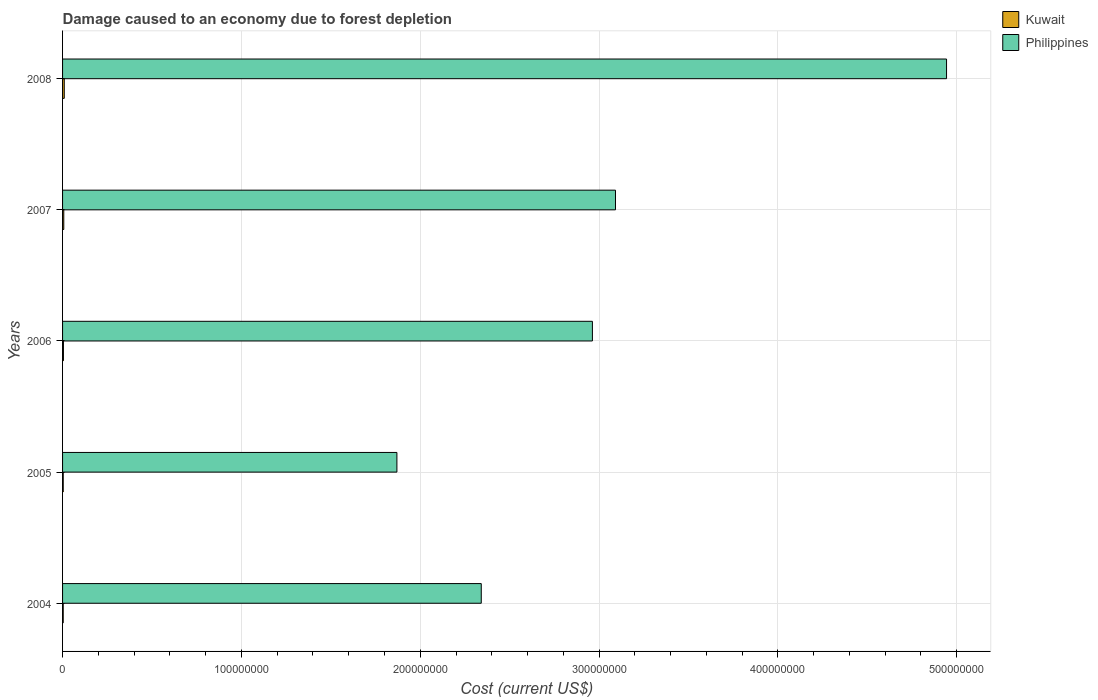How many different coloured bars are there?
Provide a short and direct response. 2. Are the number of bars on each tick of the Y-axis equal?
Keep it short and to the point. Yes. How many bars are there on the 5th tick from the top?
Your response must be concise. 2. What is the label of the 2nd group of bars from the top?
Your response must be concise. 2007. What is the cost of damage caused due to forest depletion in Philippines in 2007?
Your response must be concise. 3.09e+08. Across all years, what is the maximum cost of damage caused due to forest depletion in Kuwait?
Provide a short and direct response. 9.52e+05. Across all years, what is the minimum cost of damage caused due to forest depletion in Philippines?
Keep it short and to the point. 1.87e+08. In which year was the cost of damage caused due to forest depletion in Kuwait maximum?
Your response must be concise. 2008. What is the total cost of damage caused due to forest depletion in Philippines in the graph?
Give a very brief answer. 1.52e+09. What is the difference between the cost of damage caused due to forest depletion in Philippines in 2004 and that in 2006?
Offer a very short reply. -6.21e+07. What is the difference between the cost of damage caused due to forest depletion in Kuwait in 2005 and the cost of damage caused due to forest depletion in Philippines in 2008?
Offer a very short reply. -4.94e+08. What is the average cost of damage caused due to forest depletion in Philippines per year?
Give a very brief answer. 3.04e+08. In the year 2004, what is the difference between the cost of damage caused due to forest depletion in Philippines and cost of damage caused due to forest depletion in Kuwait?
Make the answer very short. 2.34e+08. What is the ratio of the cost of damage caused due to forest depletion in Kuwait in 2006 to that in 2008?
Ensure brevity in your answer.  0.51. What is the difference between the highest and the second highest cost of damage caused due to forest depletion in Philippines?
Provide a succinct answer. 1.85e+08. What is the difference between the highest and the lowest cost of damage caused due to forest depletion in Philippines?
Offer a very short reply. 3.07e+08. What does the 2nd bar from the top in 2004 represents?
Keep it short and to the point. Kuwait. What does the 2nd bar from the bottom in 2007 represents?
Your answer should be compact. Philippines. How many bars are there?
Make the answer very short. 10. How many years are there in the graph?
Provide a succinct answer. 5. What is the difference between two consecutive major ticks on the X-axis?
Give a very brief answer. 1.00e+08. Are the values on the major ticks of X-axis written in scientific E-notation?
Provide a short and direct response. No. How are the legend labels stacked?
Offer a terse response. Vertical. What is the title of the graph?
Offer a terse response. Damage caused to an economy due to forest depletion. What is the label or title of the X-axis?
Your answer should be very brief. Cost (current US$). What is the Cost (current US$) of Kuwait in 2004?
Make the answer very short. 3.68e+05. What is the Cost (current US$) in Philippines in 2004?
Your answer should be very brief. 2.34e+08. What is the Cost (current US$) of Kuwait in 2005?
Offer a terse response. 3.75e+05. What is the Cost (current US$) of Philippines in 2005?
Offer a very short reply. 1.87e+08. What is the Cost (current US$) in Kuwait in 2006?
Offer a very short reply. 4.88e+05. What is the Cost (current US$) in Philippines in 2006?
Offer a very short reply. 2.96e+08. What is the Cost (current US$) in Kuwait in 2007?
Offer a terse response. 6.83e+05. What is the Cost (current US$) in Philippines in 2007?
Make the answer very short. 3.09e+08. What is the Cost (current US$) of Kuwait in 2008?
Provide a succinct answer. 9.52e+05. What is the Cost (current US$) of Philippines in 2008?
Make the answer very short. 4.94e+08. Across all years, what is the maximum Cost (current US$) in Kuwait?
Keep it short and to the point. 9.52e+05. Across all years, what is the maximum Cost (current US$) of Philippines?
Your answer should be very brief. 4.94e+08. Across all years, what is the minimum Cost (current US$) of Kuwait?
Provide a short and direct response. 3.68e+05. Across all years, what is the minimum Cost (current US$) in Philippines?
Ensure brevity in your answer.  1.87e+08. What is the total Cost (current US$) in Kuwait in the graph?
Ensure brevity in your answer.  2.87e+06. What is the total Cost (current US$) in Philippines in the graph?
Provide a succinct answer. 1.52e+09. What is the difference between the Cost (current US$) of Kuwait in 2004 and that in 2005?
Give a very brief answer. -6623.41. What is the difference between the Cost (current US$) of Philippines in 2004 and that in 2005?
Your response must be concise. 4.72e+07. What is the difference between the Cost (current US$) of Kuwait in 2004 and that in 2006?
Your answer should be compact. -1.20e+05. What is the difference between the Cost (current US$) of Philippines in 2004 and that in 2006?
Give a very brief answer. -6.21e+07. What is the difference between the Cost (current US$) of Kuwait in 2004 and that in 2007?
Your response must be concise. -3.15e+05. What is the difference between the Cost (current US$) of Philippines in 2004 and that in 2007?
Offer a very short reply. -7.51e+07. What is the difference between the Cost (current US$) in Kuwait in 2004 and that in 2008?
Provide a succinct answer. -5.84e+05. What is the difference between the Cost (current US$) of Philippines in 2004 and that in 2008?
Your answer should be very brief. -2.60e+08. What is the difference between the Cost (current US$) of Kuwait in 2005 and that in 2006?
Your answer should be compact. -1.13e+05. What is the difference between the Cost (current US$) in Philippines in 2005 and that in 2006?
Offer a very short reply. -1.09e+08. What is the difference between the Cost (current US$) of Kuwait in 2005 and that in 2007?
Ensure brevity in your answer.  -3.09e+05. What is the difference between the Cost (current US$) in Philippines in 2005 and that in 2007?
Offer a terse response. -1.22e+08. What is the difference between the Cost (current US$) of Kuwait in 2005 and that in 2008?
Your answer should be compact. -5.77e+05. What is the difference between the Cost (current US$) of Philippines in 2005 and that in 2008?
Give a very brief answer. -3.07e+08. What is the difference between the Cost (current US$) of Kuwait in 2006 and that in 2007?
Your response must be concise. -1.96e+05. What is the difference between the Cost (current US$) of Philippines in 2006 and that in 2007?
Ensure brevity in your answer.  -1.29e+07. What is the difference between the Cost (current US$) in Kuwait in 2006 and that in 2008?
Give a very brief answer. -4.64e+05. What is the difference between the Cost (current US$) of Philippines in 2006 and that in 2008?
Your answer should be compact. -1.98e+08. What is the difference between the Cost (current US$) of Kuwait in 2007 and that in 2008?
Offer a very short reply. -2.69e+05. What is the difference between the Cost (current US$) of Philippines in 2007 and that in 2008?
Provide a short and direct response. -1.85e+08. What is the difference between the Cost (current US$) of Kuwait in 2004 and the Cost (current US$) of Philippines in 2005?
Make the answer very short. -1.87e+08. What is the difference between the Cost (current US$) in Kuwait in 2004 and the Cost (current US$) in Philippines in 2006?
Your response must be concise. -2.96e+08. What is the difference between the Cost (current US$) of Kuwait in 2004 and the Cost (current US$) of Philippines in 2007?
Ensure brevity in your answer.  -3.09e+08. What is the difference between the Cost (current US$) in Kuwait in 2004 and the Cost (current US$) in Philippines in 2008?
Your response must be concise. -4.94e+08. What is the difference between the Cost (current US$) of Kuwait in 2005 and the Cost (current US$) of Philippines in 2006?
Your answer should be compact. -2.96e+08. What is the difference between the Cost (current US$) of Kuwait in 2005 and the Cost (current US$) of Philippines in 2007?
Give a very brief answer. -3.09e+08. What is the difference between the Cost (current US$) in Kuwait in 2005 and the Cost (current US$) in Philippines in 2008?
Make the answer very short. -4.94e+08. What is the difference between the Cost (current US$) of Kuwait in 2006 and the Cost (current US$) of Philippines in 2007?
Provide a short and direct response. -3.09e+08. What is the difference between the Cost (current US$) in Kuwait in 2006 and the Cost (current US$) in Philippines in 2008?
Your answer should be very brief. -4.94e+08. What is the difference between the Cost (current US$) in Kuwait in 2007 and the Cost (current US$) in Philippines in 2008?
Your answer should be compact. -4.94e+08. What is the average Cost (current US$) of Kuwait per year?
Provide a succinct answer. 5.73e+05. What is the average Cost (current US$) in Philippines per year?
Make the answer very short. 3.04e+08. In the year 2004, what is the difference between the Cost (current US$) in Kuwait and Cost (current US$) in Philippines?
Provide a short and direct response. -2.34e+08. In the year 2005, what is the difference between the Cost (current US$) in Kuwait and Cost (current US$) in Philippines?
Your answer should be very brief. -1.87e+08. In the year 2006, what is the difference between the Cost (current US$) of Kuwait and Cost (current US$) of Philippines?
Give a very brief answer. -2.96e+08. In the year 2007, what is the difference between the Cost (current US$) in Kuwait and Cost (current US$) in Philippines?
Provide a succinct answer. -3.08e+08. In the year 2008, what is the difference between the Cost (current US$) in Kuwait and Cost (current US$) in Philippines?
Provide a short and direct response. -4.93e+08. What is the ratio of the Cost (current US$) in Kuwait in 2004 to that in 2005?
Provide a succinct answer. 0.98. What is the ratio of the Cost (current US$) of Philippines in 2004 to that in 2005?
Give a very brief answer. 1.25. What is the ratio of the Cost (current US$) in Kuwait in 2004 to that in 2006?
Offer a very short reply. 0.75. What is the ratio of the Cost (current US$) in Philippines in 2004 to that in 2006?
Ensure brevity in your answer.  0.79. What is the ratio of the Cost (current US$) of Kuwait in 2004 to that in 2007?
Offer a terse response. 0.54. What is the ratio of the Cost (current US$) of Philippines in 2004 to that in 2007?
Offer a very short reply. 0.76. What is the ratio of the Cost (current US$) in Kuwait in 2004 to that in 2008?
Your answer should be very brief. 0.39. What is the ratio of the Cost (current US$) in Philippines in 2004 to that in 2008?
Offer a terse response. 0.47. What is the ratio of the Cost (current US$) of Kuwait in 2005 to that in 2006?
Your response must be concise. 0.77. What is the ratio of the Cost (current US$) in Philippines in 2005 to that in 2006?
Keep it short and to the point. 0.63. What is the ratio of the Cost (current US$) of Kuwait in 2005 to that in 2007?
Offer a very short reply. 0.55. What is the ratio of the Cost (current US$) in Philippines in 2005 to that in 2007?
Your answer should be compact. 0.6. What is the ratio of the Cost (current US$) of Kuwait in 2005 to that in 2008?
Ensure brevity in your answer.  0.39. What is the ratio of the Cost (current US$) in Philippines in 2005 to that in 2008?
Ensure brevity in your answer.  0.38. What is the ratio of the Cost (current US$) in Kuwait in 2006 to that in 2007?
Ensure brevity in your answer.  0.71. What is the ratio of the Cost (current US$) of Kuwait in 2006 to that in 2008?
Give a very brief answer. 0.51. What is the ratio of the Cost (current US$) in Philippines in 2006 to that in 2008?
Your response must be concise. 0.6. What is the ratio of the Cost (current US$) of Kuwait in 2007 to that in 2008?
Ensure brevity in your answer.  0.72. What is the ratio of the Cost (current US$) of Philippines in 2007 to that in 2008?
Keep it short and to the point. 0.63. What is the difference between the highest and the second highest Cost (current US$) in Kuwait?
Give a very brief answer. 2.69e+05. What is the difference between the highest and the second highest Cost (current US$) of Philippines?
Provide a short and direct response. 1.85e+08. What is the difference between the highest and the lowest Cost (current US$) in Kuwait?
Your response must be concise. 5.84e+05. What is the difference between the highest and the lowest Cost (current US$) in Philippines?
Offer a terse response. 3.07e+08. 